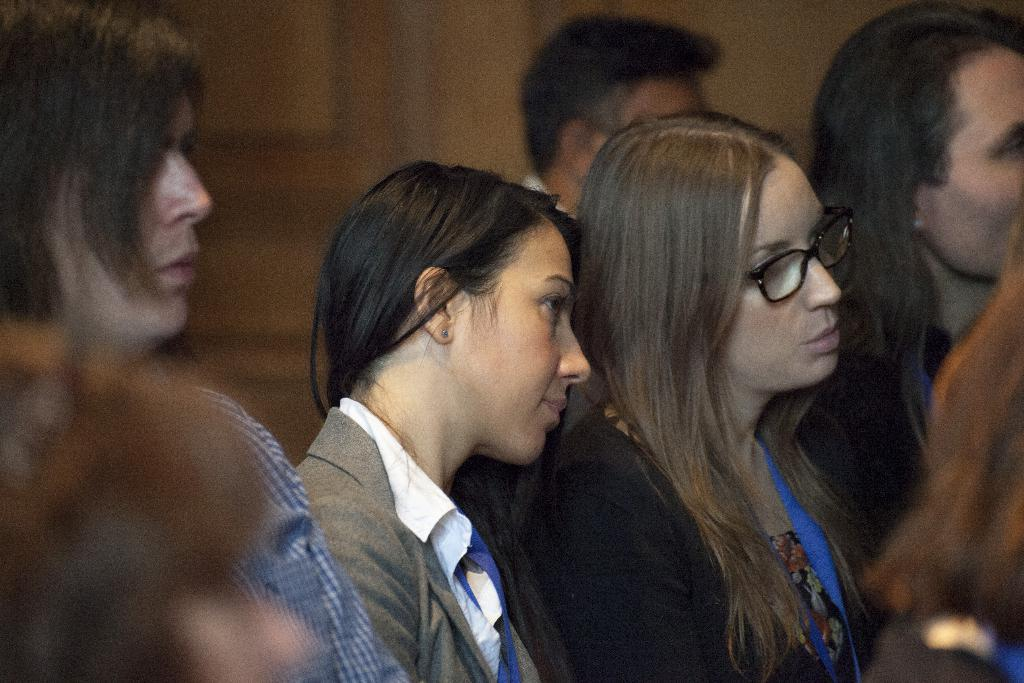How many people are in the image? There is a group of people in the image. What are the people doing in the image? The people are standing together and watching something. What type of pear is hanging from the string in the image? There is no pear or string present in the image. 